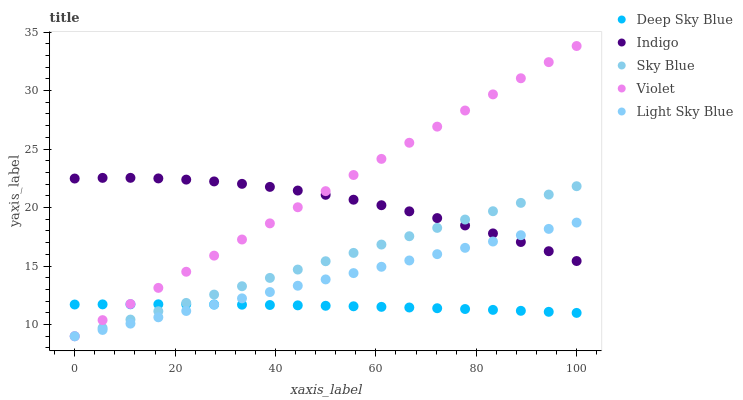Does Deep Sky Blue have the minimum area under the curve?
Answer yes or no. Yes. Does Violet have the maximum area under the curve?
Answer yes or no. Yes. Does Light Sky Blue have the minimum area under the curve?
Answer yes or no. No. Does Light Sky Blue have the maximum area under the curve?
Answer yes or no. No. Is Violet the smoothest?
Answer yes or no. Yes. Is Indigo the roughest?
Answer yes or no. Yes. Is Light Sky Blue the smoothest?
Answer yes or no. No. Is Light Sky Blue the roughest?
Answer yes or no. No. Does Sky Blue have the lowest value?
Answer yes or no. Yes. Does Indigo have the lowest value?
Answer yes or no. No. Does Violet have the highest value?
Answer yes or no. Yes. Does Light Sky Blue have the highest value?
Answer yes or no. No. Is Deep Sky Blue less than Indigo?
Answer yes or no. Yes. Is Indigo greater than Deep Sky Blue?
Answer yes or no. Yes. Does Indigo intersect Light Sky Blue?
Answer yes or no. Yes. Is Indigo less than Light Sky Blue?
Answer yes or no. No. Is Indigo greater than Light Sky Blue?
Answer yes or no. No. Does Deep Sky Blue intersect Indigo?
Answer yes or no. No. 